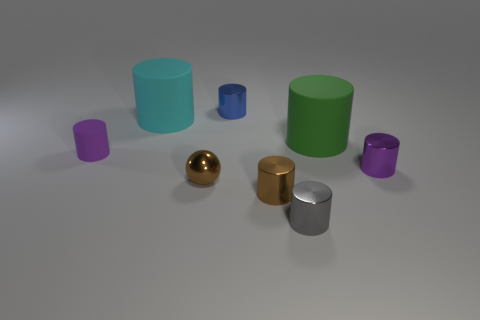Can you describe the lighting and shadows in the image? The lighting in the image appears to be coming from the upper left, casting soft shadows towards the right of the objects. The shadows vary in length and sharpness, suggesting a single diffuse light source, which creates a gentle and realistic representation of the objects' forms. Does the lighting reveal anything about the texture of the objects? Yes, the lighting accentuates the textures of the objects. It highlights the smoothness of the shiny objects, like the metal cylinder and golden sphere, by reflecting light strongly at certain angles. The matte cylinders, on the other hand, have more uniformly diffused reflections, indicating their non-glossy texture. 